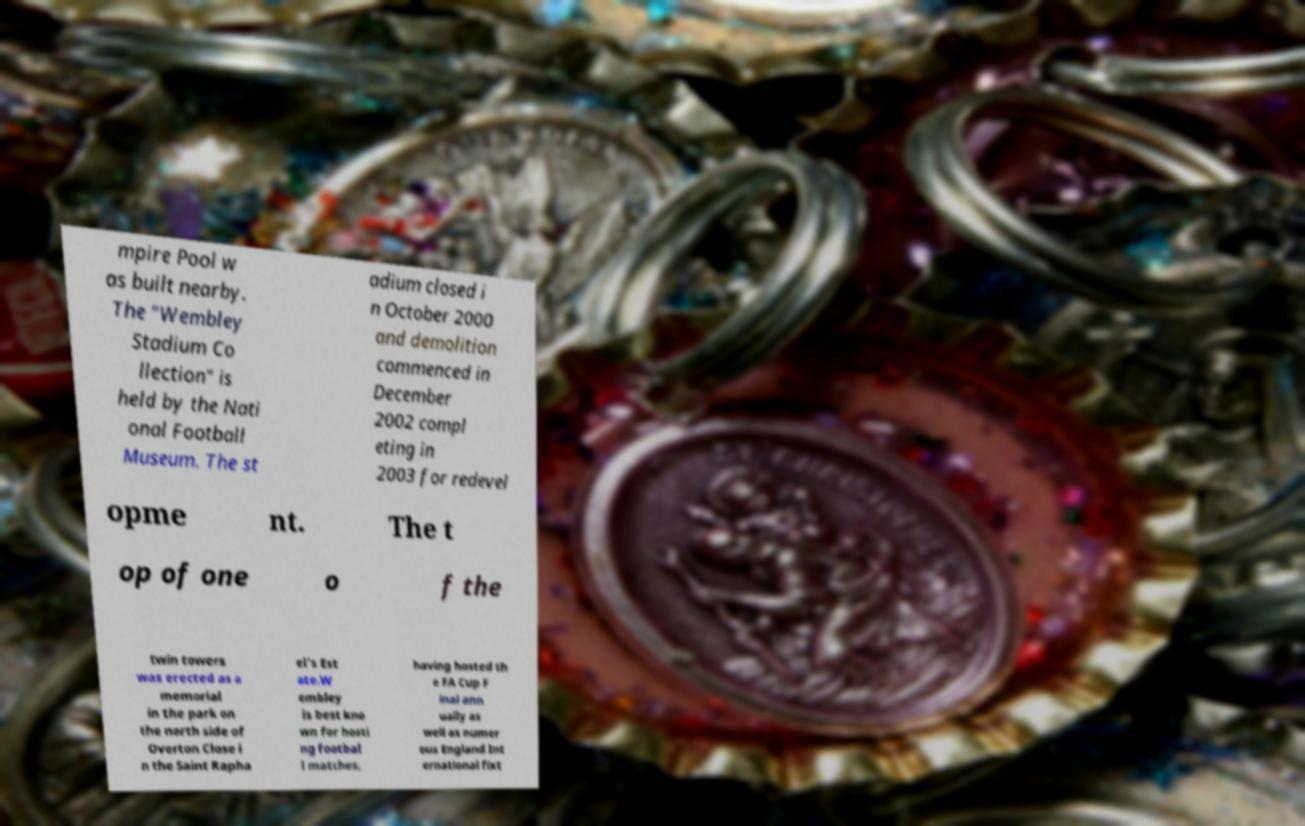Please read and relay the text visible in this image. What does it say? mpire Pool w as built nearby. The "Wembley Stadium Co llection" is held by the Nati onal Football Museum. The st adium closed i n October 2000 and demolition commenced in December 2002 compl eting in 2003 for redevel opme nt. The t op of one o f the twin towers was erected as a memorial in the park on the north side of Overton Close i n the Saint Rapha el's Est ate.W embley is best kno wn for hosti ng footbal l matches, having hosted th e FA Cup F inal ann ually as well as numer ous England Int ernational fixt 